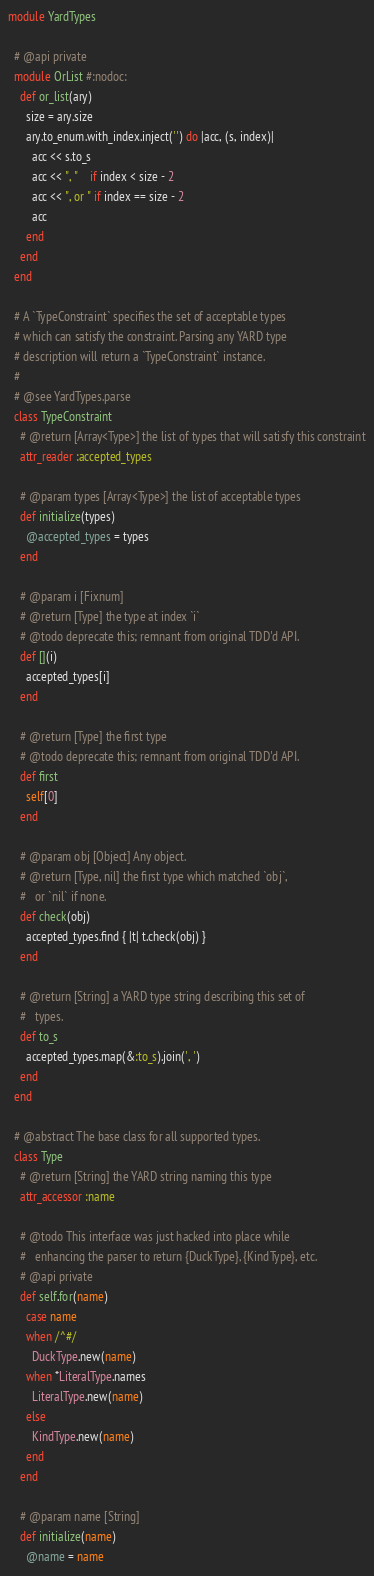Convert code to text. <code><loc_0><loc_0><loc_500><loc_500><_Ruby_>module YardTypes

  # @api private
  module OrList #:nodoc:
    def or_list(ary)
      size = ary.size
      ary.to_enum.with_index.inject('') do |acc, (s, index)|
        acc << s.to_s
        acc << ", "    if index < size - 2
        acc << ", or " if index == size - 2
        acc
      end
    end
  end

  # A `TypeConstraint` specifies the set of acceptable types
  # which can satisfy the constraint. Parsing any YARD type
  # description will return a `TypeConstraint` instance.
  #
  # @see YardTypes.parse
  class TypeConstraint
    # @return [Array<Type>] the list of types that will satisfy this constraint
    attr_reader :accepted_types

    # @param types [Array<Type>] the list of acceptable types
    def initialize(types)
      @accepted_types = types
    end

    # @param i [Fixnum]
    # @return [Type] the type at index `i`
    # @todo deprecate this; remnant from original TDD'd API.
    def [](i)
      accepted_types[i]
    end

    # @return [Type] the first type
    # @todo deprecate this; remnant from original TDD'd API.
    def first
      self[0]
    end

    # @param obj [Object] Any object.
    # @return [Type, nil] the first type which matched `obj`,
    #   or `nil` if none.
    def check(obj)
      accepted_types.find { |t| t.check(obj) }
    end

    # @return [String] a YARD type string describing this set of
    #   types.
    def to_s
      accepted_types.map(&:to_s).join(', ')
    end
  end

  # @abstract The base class for all supported types.
  class Type
    # @return [String] the YARD string naming this type
    attr_accessor :name

    # @todo This interface was just hacked into place while
    #   enhancing the parser to return {DuckType}, {KindType}, etc.
    # @api private
    def self.for(name)
      case name
      when /^#/
        DuckType.new(name)
      when *LiteralType.names
        LiteralType.new(name)
      else
        KindType.new(name)
      end
    end

    # @param name [String]
    def initialize(name)
      @name = name</code> 